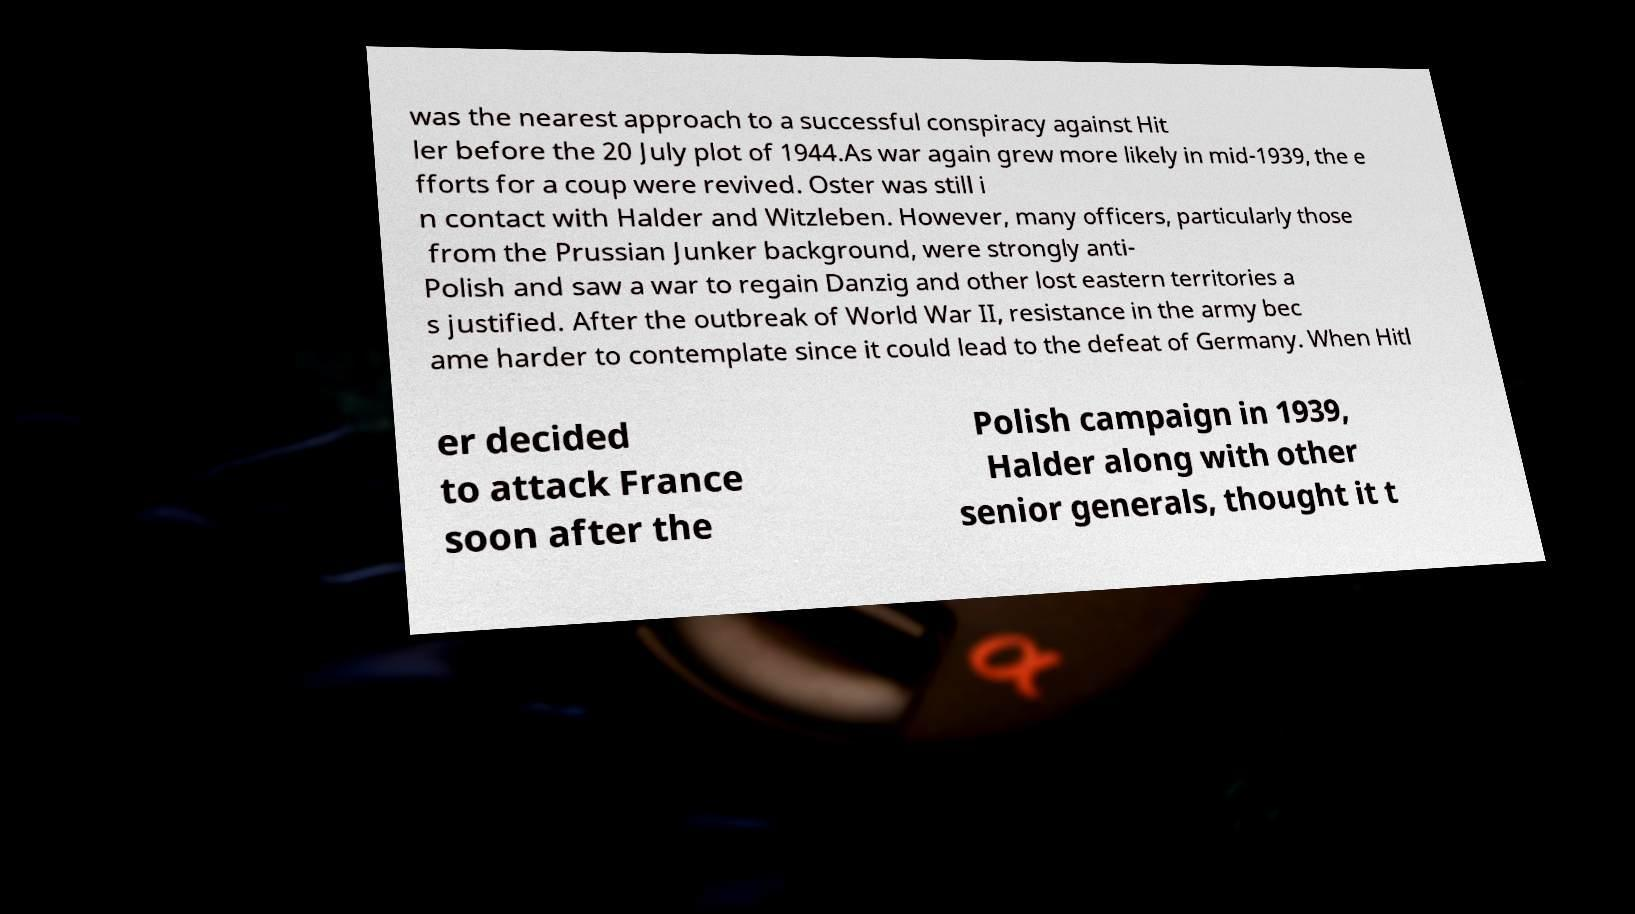Can you accurately transcribe the text from the provided image for me? was the nearest approach to a successful conspiracy against Hit ler before the 20 July plot of 1944.As war again grew more likely in mid-1939, the e fforts for a coup were revived. Oster was still i n contact with Halder and Witzleben. However, many officers, particularly those from the Prussian Junker background, were strongly anti- Polish and saw a war to regain Danzig and other lost eastern territories a s justified. After the outbreak of World War II, resistance in the army bec ame harder to contemplate since it could lead to the defeat of Germany. When Hitl er decided to attack France soon after the Polish campaign in 1939, Halder along with other senior generals, thought it t 